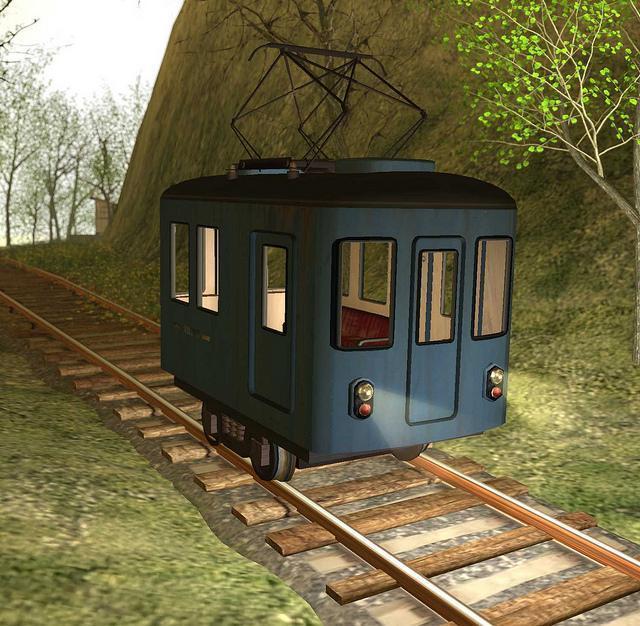How many seats can you see?
Give a very brief answer. 1. 